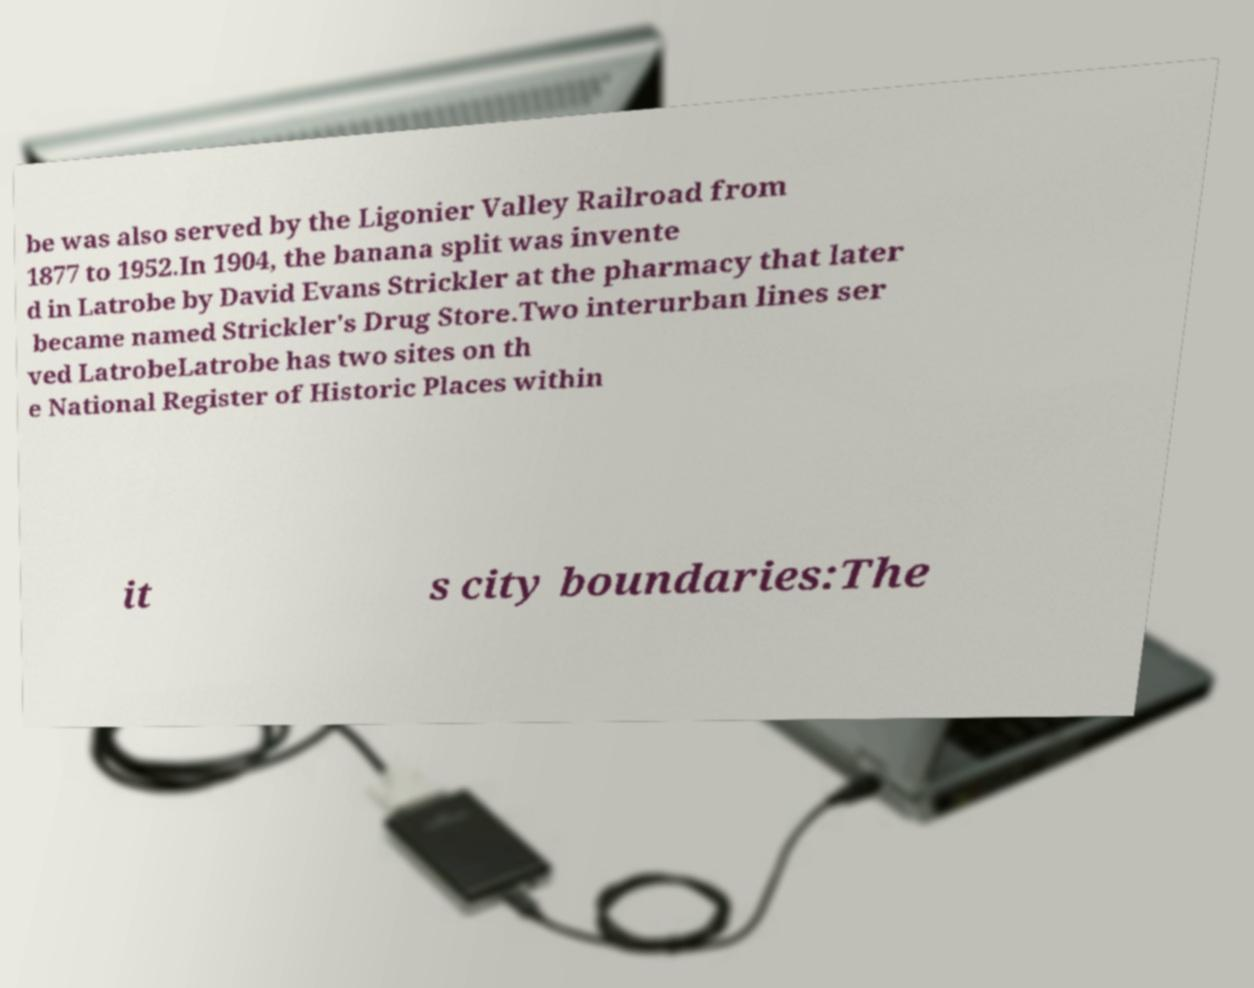What messages or text are displayed in this image? I need them in a readable, typed format. be was also served by the Ligonier Valley Railroad from 1877 to 1952.In 1904, the banana split was invente d in Latrobe by David Evans Strickler at the pharmacy that later became named Strickler's Drug Store.Two interurban lines ser ved LatrobeLatrobe has two sites on th e National Register of Historic Places within it s city boundaries:The 